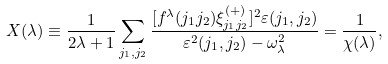Convert formula to latex. <formula><loc_0><loc_0><loc_500><loc_500>X ( \lambda ) \equiv \frac { 1 } { 2 \lambda + 1 } \sum _ { j _ { 1 } , j _ { 2 } } \frac { [ f ^ { \lambda } ( j _ { 1 } j _ { 2 } ) \xi ^ { ( + ) } _ { j _ { 1 } j _ { 2 } } ] ^ { 2 } \varepsilon ( j _ { 1 } , j _ { 2 } ) } { \varepsilon ^ { 2 } ( j _ { 1 } , j _ { 2 } ) - \omega _ { \lambda } ^ { 2 } } = \frac { 1 } { \chi ( \lambda ) } ,</formula> 